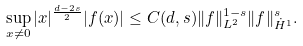Convert formula to latex. <formula><loc_0><loc_0><loc_500><loc_500>\sup _ { x \ne 0 } | x | ^ { \frac { d - 2 s } { 2 } } | f ( x ) | \leq C ( d , s ) \| f \| ^ { 1 - s } _ { L ^ { 2 } } \| f \| ^ { s } _ { \dot { H } ^ { 1 } } .</formula> 